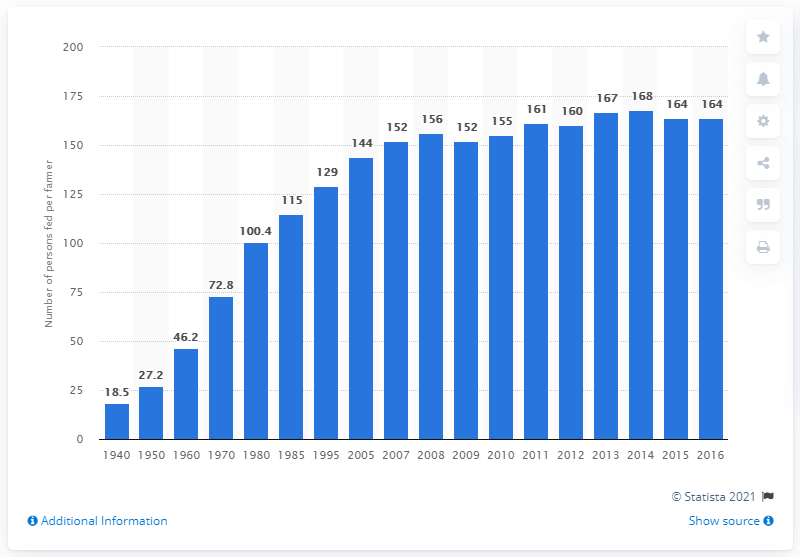Point out several critical features in this image. In 1940, the average number of people fed per farmer was 18.5. 